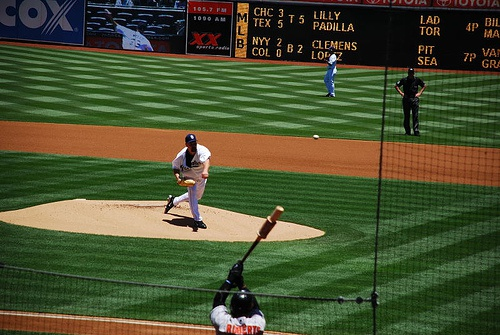Describe the objects in this image and their specific colors. I can see tv in black, gray, and navy tones, people in black, lavender, gray, and darkgray tones, people in black, gray, and white tones, people in black and darkgreen tones, and baseball bat in black, maroon, darkgreen, and tan tones in this image. 